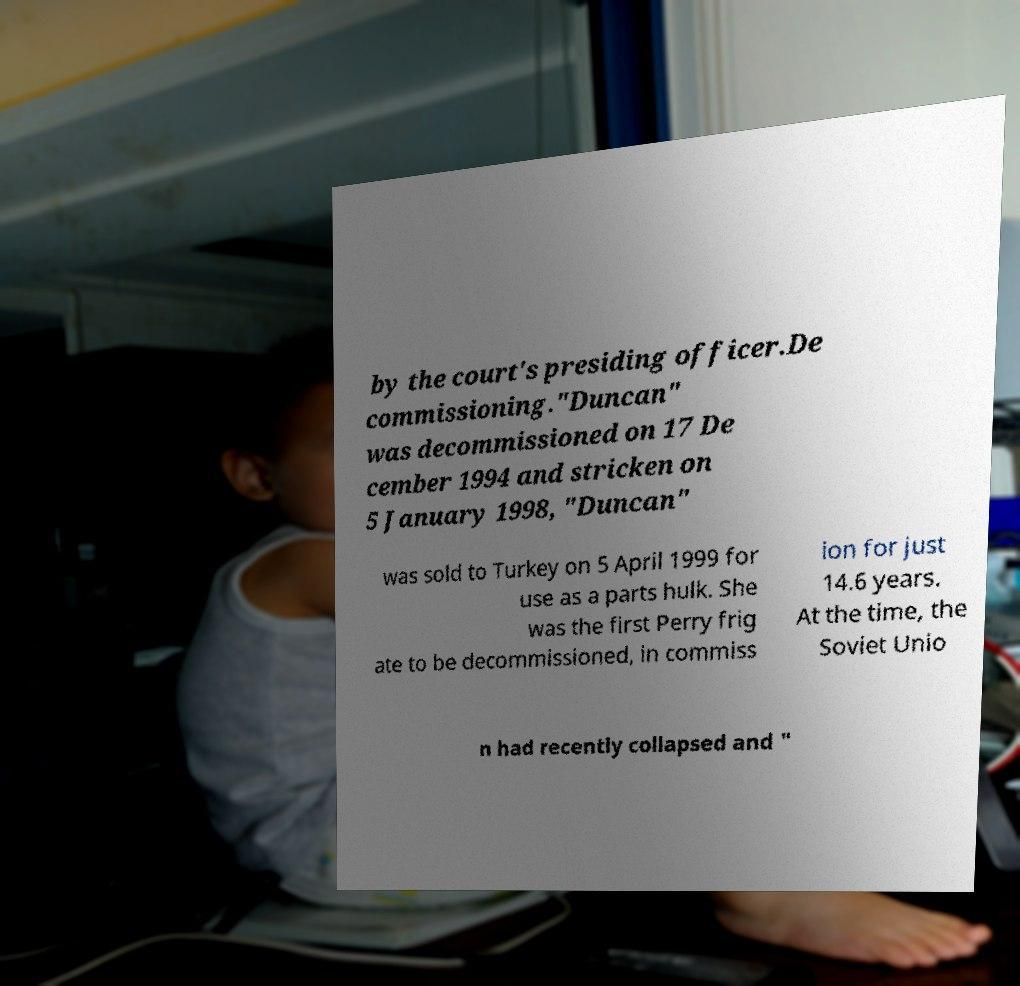Please read and relay the text visible in this image. What does it say? by the court's presiding officer.De commissioning."Duncan" was decommissioned on 17 De cember 1994 and stricken on 5 January 1998, "Duncan" was sold to Turkey on 5 April 1999 for use as a parts hulk. She was the first Perry frig ate to be decommissioned, in commiss ion for just 14.6 years. At the time, the Soviet Unio n had recently collapsed and " 